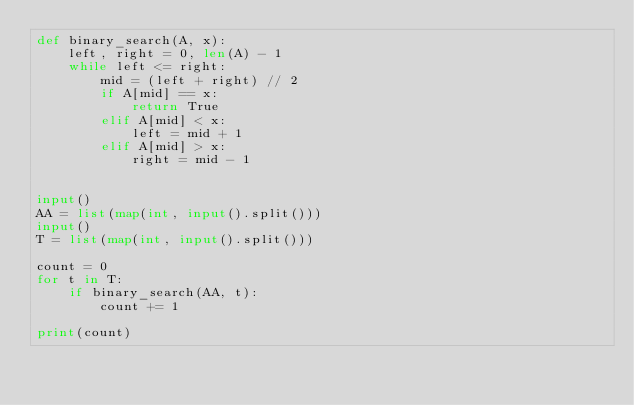Convert code to text. <code><loc_0><loc_0><loc_500><loc_500><_Python_>def binary_search(A, x):
    left, right = 0, len(A) - 1
    while left <= right:
        mid = (left + right) // 2
        if A[mid] == x:
            return True
        elif A[mid] < x:
            left = mid + 1
        elif A[mid] > x:
            right = mid - 1


input()
AA = list(map(int, input().split()))
input()
T = list(map(int, input().split()))

count = 0
for t in T:
    if binary_search(AA, t):
        count += 1

print(count)

</code> 